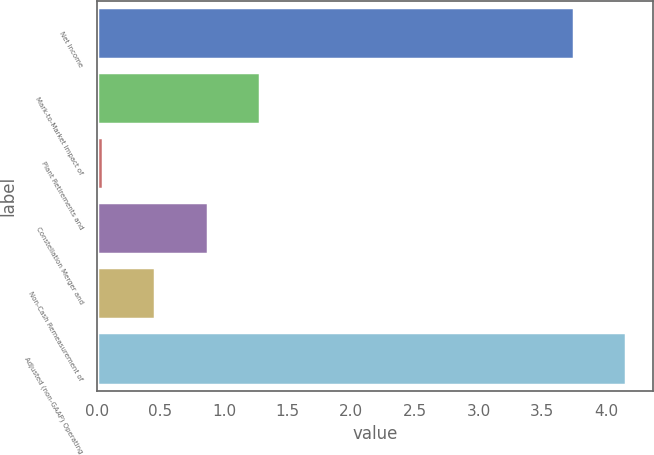Convert chart to OTSL. <chart><loc_0><loc_0><loc_500><loc_500><bar_chart><fcel>Net Income<fcel>Mark-to-Market Impact of<fcel>Plant Retirements and<fcel>Constellation Merger and<fcel>Non-Cash Remeasurement of<fcel>Adjusted (non-GAAP) Operating<nl><fcel>3.75<fcel>1.28<fcel>0.05<fcel>0.87<fcel>0.46<fcel>4.16<nl></chart> 